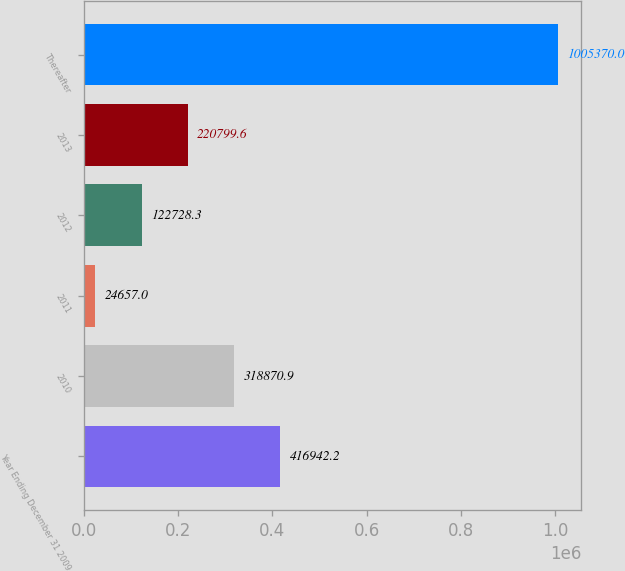<chart> <loc_0><loc_0><loc_500><loc_500><bar_chart><fcel>Year Ending December 31 2009<fcel>2010<fcel>2011<fcel>2012<fcel>2013<fcel>Thereafter<nl><fcel>416942<fcel>318871<fcel>24657<fcel>122728<fcel>220800<fcel>1.00537e+06<nl></chart> 